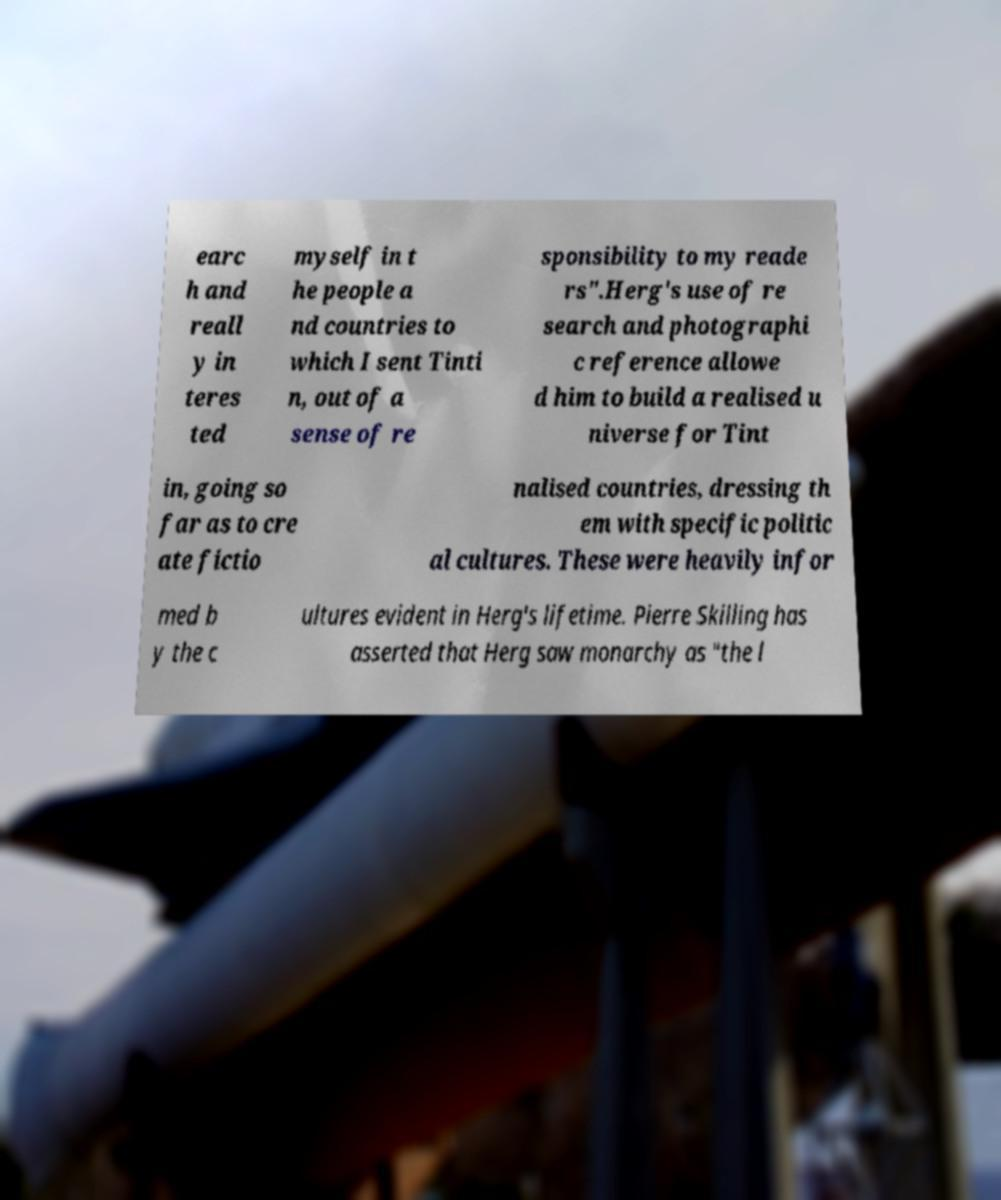There's text embedded in this image that I need extracted. Can you transcribe it verbatim? earc h and reall y in teres ted myself in t he people a nd countries to which I sent Tinti n, out of a sense of re sponsibility to my reade rs".Herg's use of re search and photographi c reference allowe d him to build a realised u niverse for Tint in, going so far as to cre ate fictio nalised countries, dressing th em with specific politic al cultures. These were heavily infor med b y the c ultures evident in Herg's lifetime. Pierre Skilling has asserted that Herg saw monarchy as "the l 